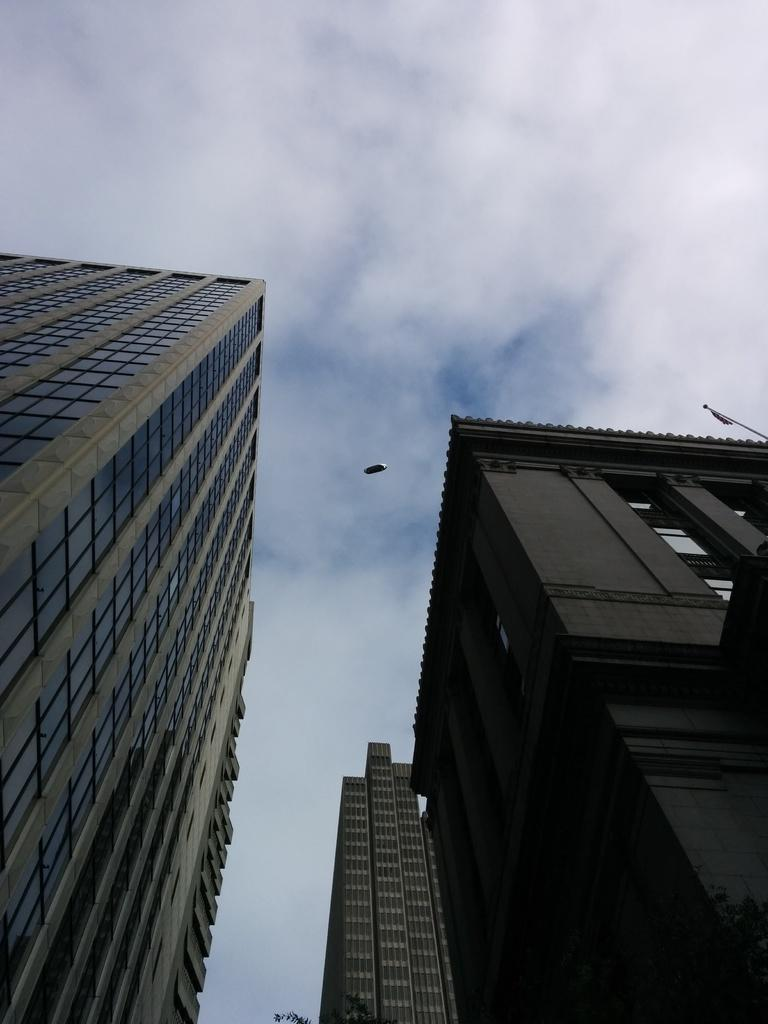What type of structures can be seen on the right side of the image? There are buildings and skyscrapers on the right side of the image. What type of structures can be seen on the left side of the image? There are buildings and skyscrapers on the left side of the image. What is visible at the top of the image? The sky is visible at the top of the image. How many legs does the deer have in the image? There is no deer present in the image. What is the governor's role in the image? There is no governor present in the image. 